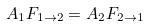<formula> <loc_0><loc_0><loc_500><loc_500>A _ { 1 } F _ { 1 \rightarrow 2 } = A _ { 2 } F _ { 2 \rightarrow 1 }</formula> 